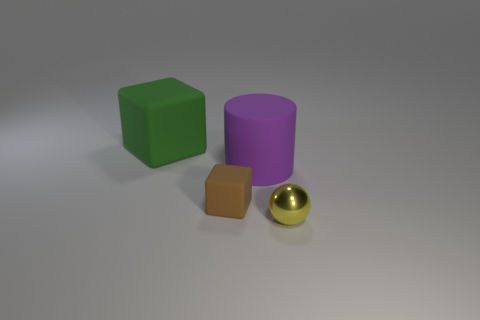Are there any big matte objects that have the same color as the big rubber cylinder?
Ensure brevity in your answer.  No. How many other things are there of the same shape as the small yellow object?
Give a very brief answer. 0. What shape is the object in front of the tiny rubber cube?
Ensure brevity in your answer.  Sphere. Does the tiny brown matte object have the same shape as the big matte object that is behind the large purple cylinder?
Your response must be concise. Yes. What is the size of the object that is in front of the large cylinder and on the right side of the brown thing?
Offer a very short reply. Small. What is the color of the object that is to the left of the purple rubber cylinder and behind the tiny block?
Your response must be concise. Green. Is there anything else that has the same material as the tiny brown object?
Ensure brevity in your answer.  Yes. Are there fewer green matte blocks that are behind the big purple cylinder than rubber objects in front of the large green rubber object?
Provide a short and direct response. Yes. Are there any other things that have the same color as the big rubber cube?
Keep it short and to the point. No. What shape is the yellow thing?
Offer a very short reply. Sphere. 